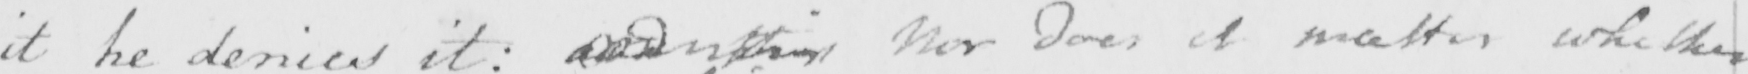Transcribe the text shown in this historical manuscript line. it he denies it :  and this Nor does it matter whether 